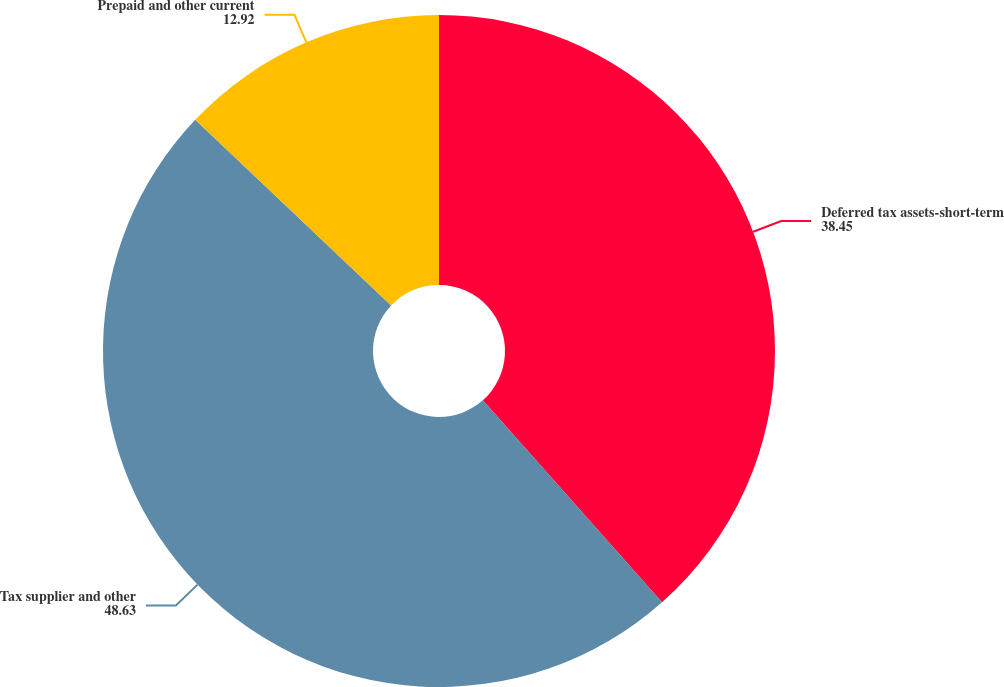<chart> <loc_0><loc_0><loc_500><loc_500><pie_chart><fcel>Deferred tax assets-short-term<fcel>Tax supplier and other<fcel>Prepaid and other current<nl><fcel>38.45%<fcel>48.63%<fcel>12.92%<nl></chart> 